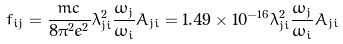<formula> <loc_0><loc_0><loc_500><loc_500>f _ { i j } = \frac { m c } { 8 { \pi } ^ { 2 } { e ^ { 2 } } } { \lambda ^ { 2 } _ { j i } } \frac { { \omega } _ { j } } { { \omega } _ { i } } A _ { j i } = 1 . 4 9 \times 1 0 ^ { - 1 6 } \lambda ^ { 2 } _ { j i } \frac { { \omega } _ { j } } { { \omega } _ { i } } A _ { j i }</formula> 